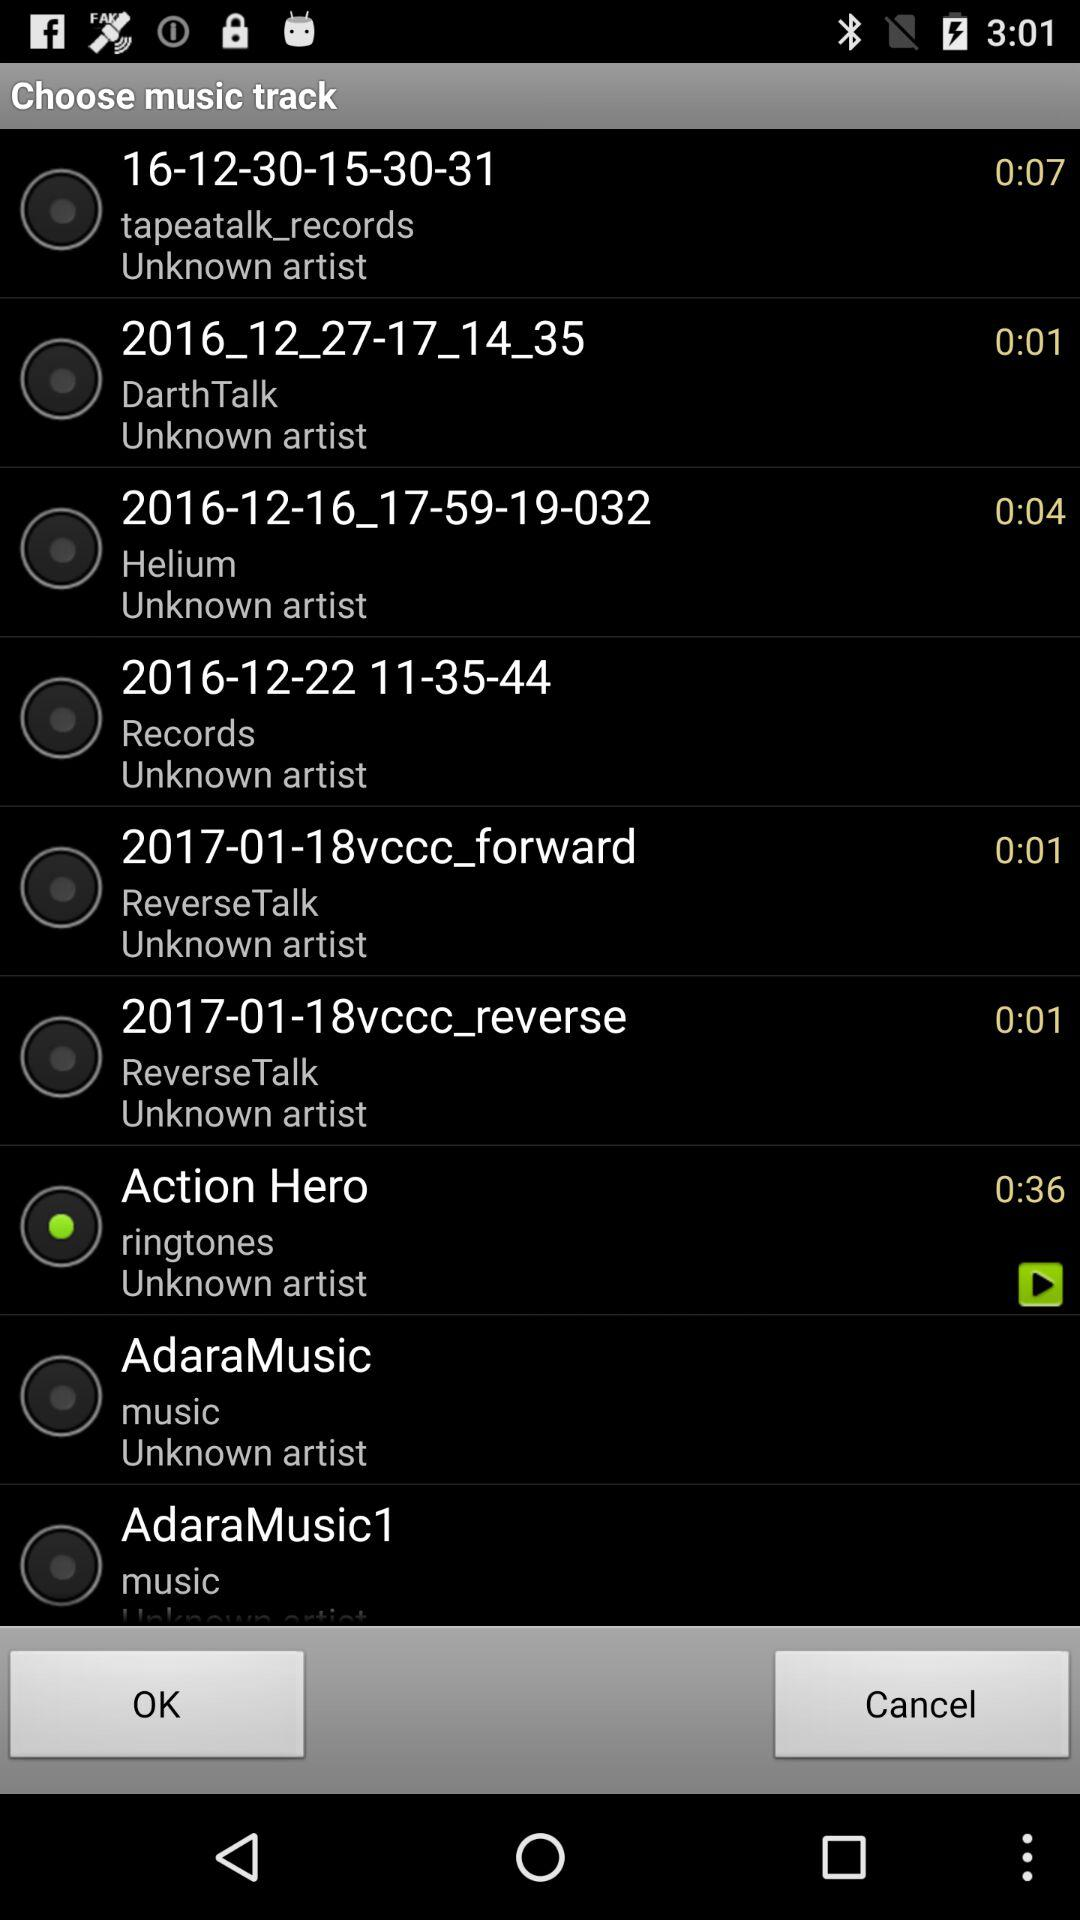What is the length of "Action Hero" ringtone? The length is 36 seconds. 